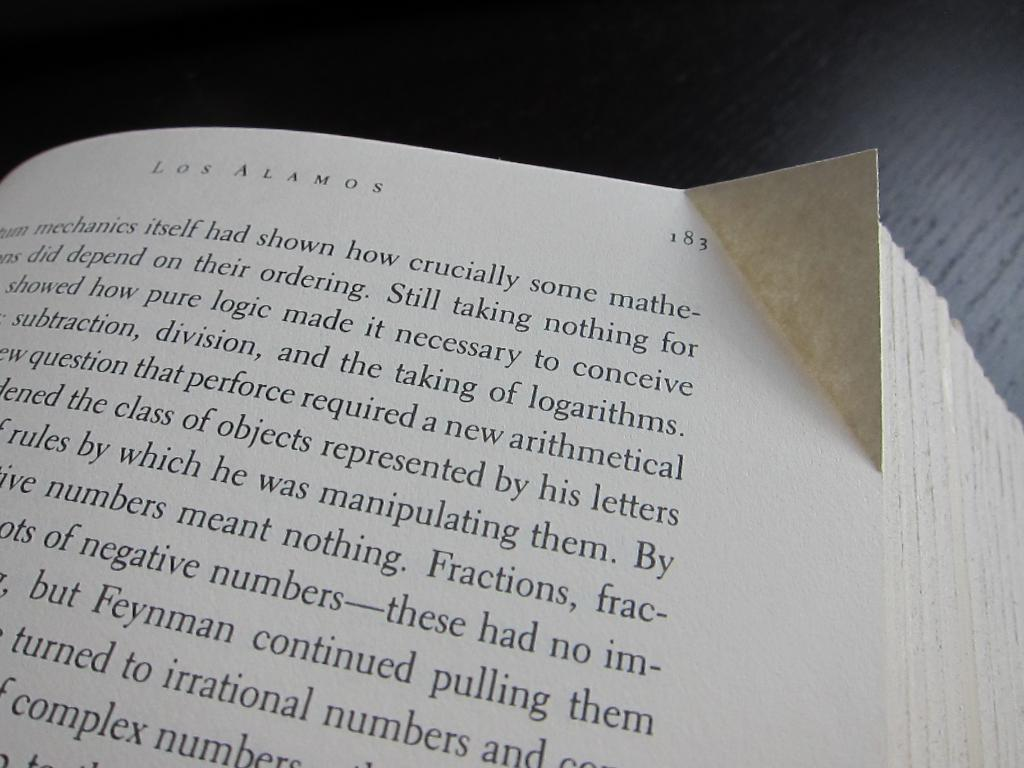<image>
Describe the image concisely. A text book opened to a page with the title Los Alamos on top. 